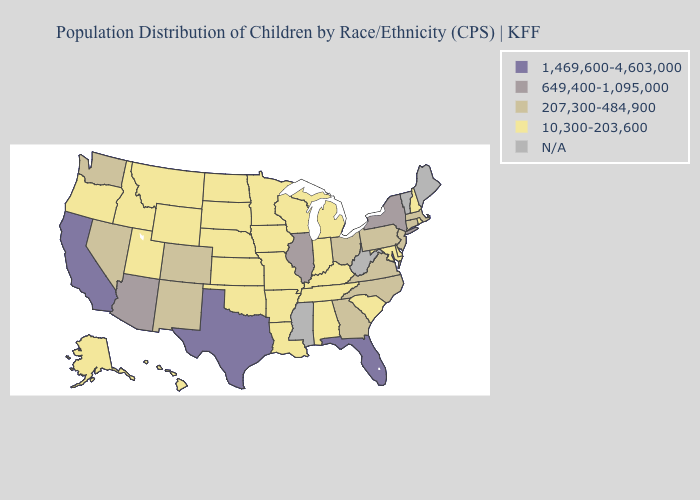Name the states that have a value in the range N/A?
Quick response, please. Maine, Mississippi, Vermont, West Virginia. What is the highest value in the MidWest ?
Answer briefly. 649,400-1,095,000. Which states have the lowest value in the Northeast?
Be succinct. New Hampshire, Rhode Island. What is the lowest value in states that border Pennsylvania?
Give a very brief answer. 10,300-203,600. Name the states that have a value in the range 649,400-1,095,000?
Concise answer only. Arizona, Illinois, New York. Name the states that have a value in the range N/A?
Short answer required. Maine, Mississippi, Vermont, West Virginia. What is the value of Maryland?
Concise answer only. 10,300-203,600. Name the states that have a value in the range 207,300-484,900?
Quick response, please. Colorado, Connecticut, Georgia, Massachusetts, Nevada, New Jersey, New Mexico, North Carolina, Ohio, Pennsylvania, Virginia, Washington. Name the states that have a value in the range 649,400-1,095,000?
Be succinct. Arizona, Illinois, New York. What is the value of Virginia?
Give a very brief answer. 207,300-484,900. What is the lowest value in the USA?
Quick response, please. 10,300-203,600. Name the states that have a value in the range N/A?
Answer briefly. Maine, Mississippi, Vermont, West Virginia. 